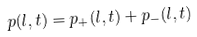<formula> <loc_0><loc_0><loc_500><loc_500>p ( l , t ) = p _ { + } ( l , t ) + p _ { - } ( l , t )</formula> 